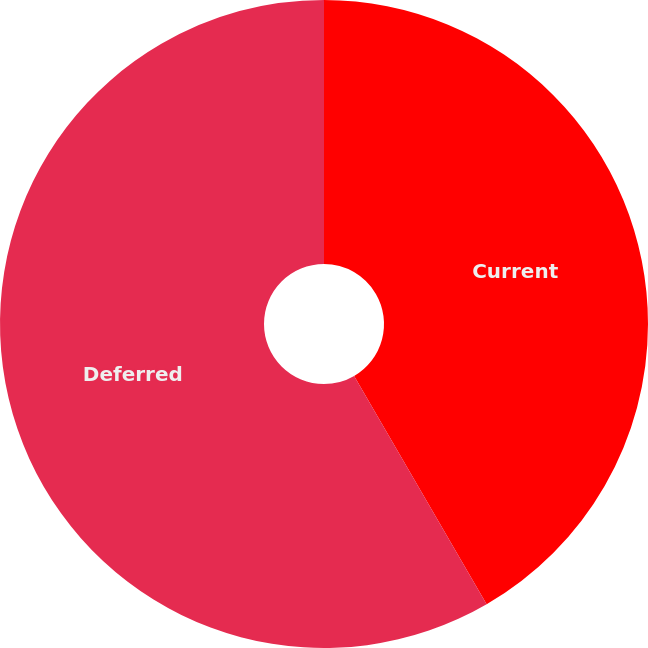Convert chart. <chart><loc_0><loc_0><loc_500><loc_500><pie_chart><fcel>Current<fcel>Deferred<nl><fcel>41.63%<fcel>58.37%<nl></chart> 